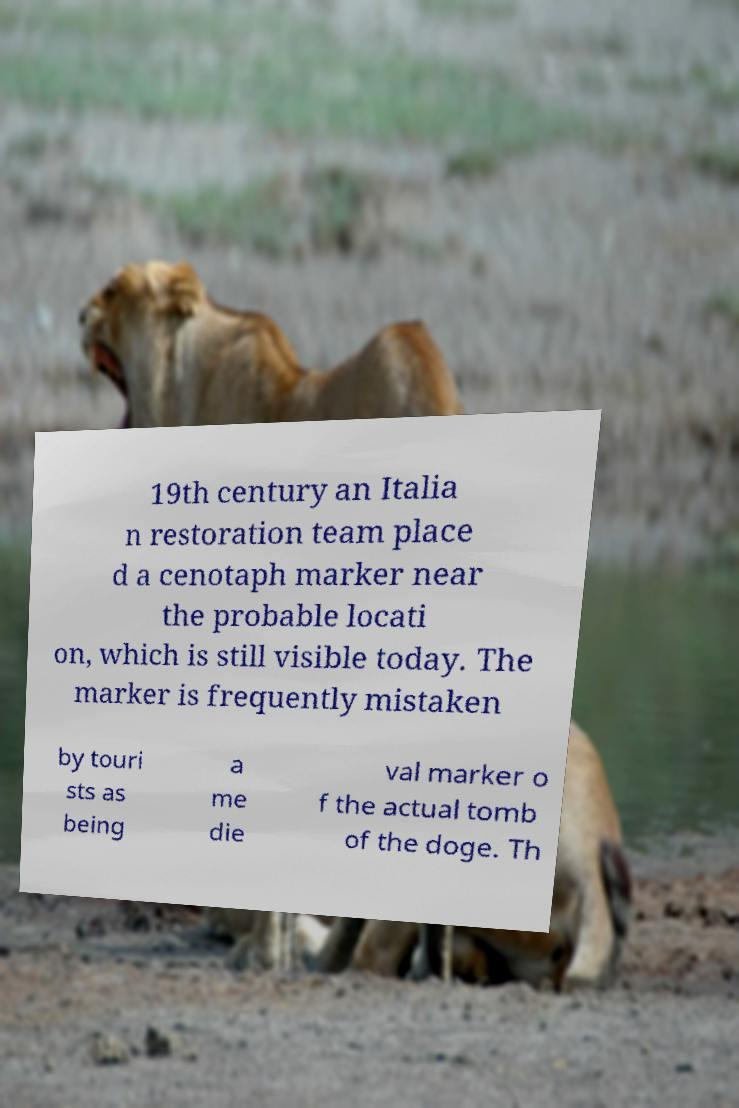Could you assist in decoding the text presented in this image and type it out clearly? 19th century an Italia n restoration team place d a cenotaph marker near the probable locati on, which is still visible today. The marker is frequently mistaken by touri sts as being a me die val marker o f the actual tomb of the doge. Th 